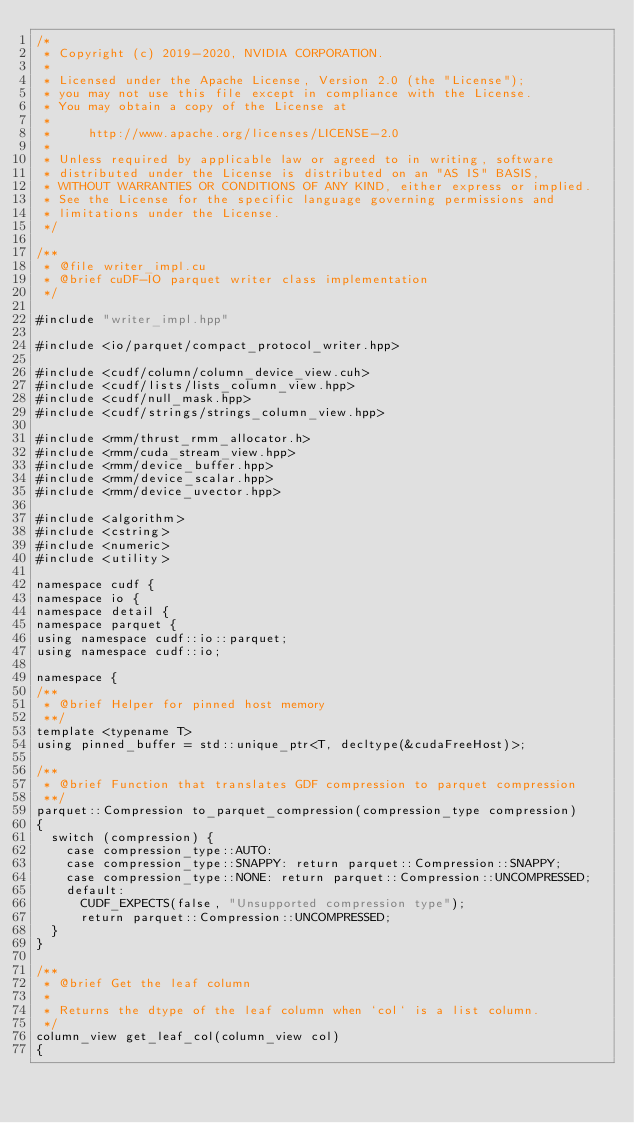Convert code to text. <code><loc_0><loc_0><loc_500><loc_500><_Cuda_>/*
 * Copyright (c) 2019-2020, NVIDIA CORPORATION.
 *
 * Licensed under the Apache License, Version 2.0 (the "License");
 * you may not use this file except in compliance with the License.
 * You may obtain a copy of the License at
 *
 *     http://www.apache.org/licenses/LICENSE-2.0
 *
 * Unless required by applicable law or agreed to in writing, software
 * distributed under the License is distributed on an "AS IS" BASIS,
 * WITHOUT WARRANTIES OR CONDITIONS OF ANY KIND, either express or implied.
 * See the License for the specific language governing permissions and
 * limitations under the License.
 */

/**
 * @file writer_impl.cu
 * @brief cuDF-IO parquet writer class implementation
 */

#include "writer_impl.hpp"

#include <io/parquet/compact_protocol_writer.hpp>

#include <cudf/column/column_device_view.cuh>
#include <cudf/lists/lists_column_view.hpp>
#include <cudf/null_mask.hpp>
#include <cudf/strings/strings_column_view.hpp>

#include <rmm/thrust_rmm_allocator.h>
#include <rmm/cuda_stream_view.hpp>
#include <rmm/device_buffer.hpp>
#include <rmm/device_scalar.hpp>
#include <rmm/device_uvector.hpp>

#include <algorithm>
#include <cstring>
#include <numeric>
#include <utility>

namespace cudf {
namespace io {
namespace detail {
namespace parquet {
using namespace cudf::io::parquet;
using namespace cudf::io;

namespace {
/**
 * @brief Helper for pinned host memory
 **/
template <typename T>
using pinned_buffer = std::unique_ptr<T, decltype(&cudaFreeHost)>;

/**
 * @brief Function that translates GDF compression to parquet compression
 **/
parquet::Compression to_parquet_compression(compression_type compression)
{
  switch (compression) {
    case compression_type::AUTO:
    case compression_type::SNAPPY: return parquet::Compression::SNAPPY;
    case compression_type::NONE: return parquet::Compression::UNCOMPRESSED;
    default:
      CUDF_EXPECTS(false, "Unsupported compression type");
      return parquet::Compression::UNCOMPRESSED;
  }
}

/**
 * @brief Get the leaf column
 *
 * Returns the dtype of the leaf column when `col` is a list column.
 */
column_view get_leaf_col(column_view col)
{</code> 